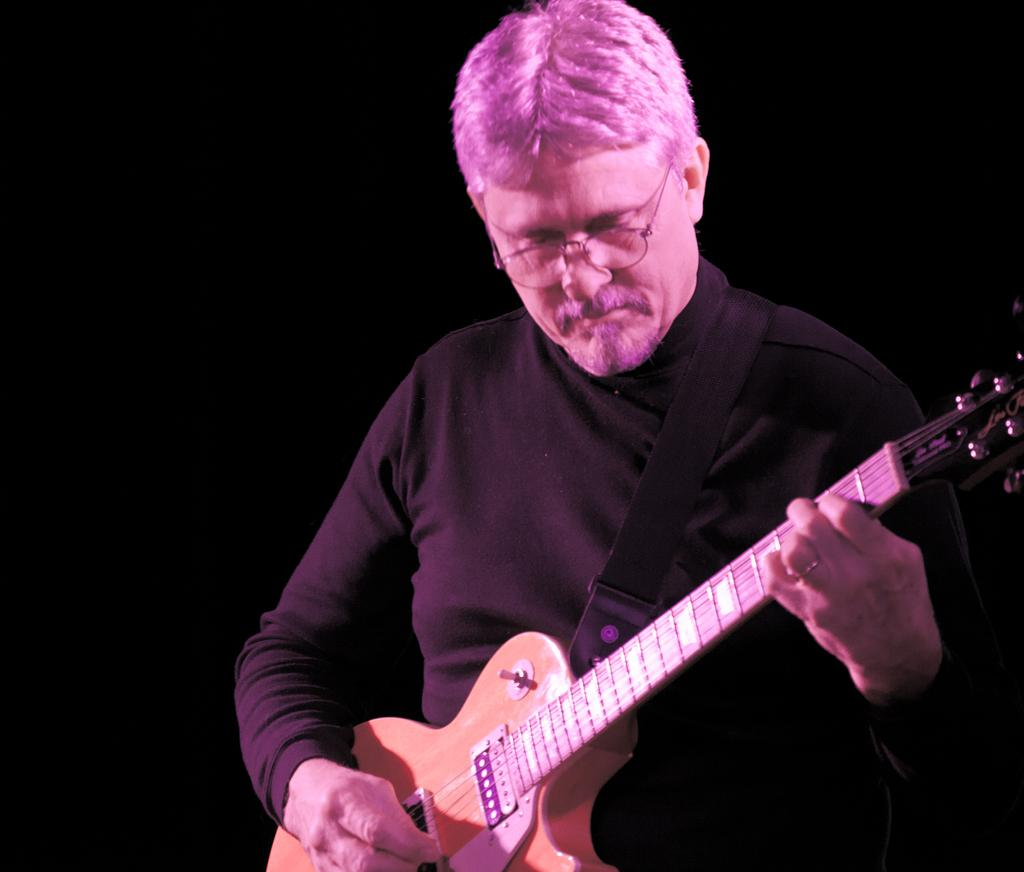Who is the main subject in the image? There is a man in the image. What is the man wearing? The man is wearing spectacles. What is the man holding in the image? The man is holding a guitar. What is the man doing with the guitar? The man is playing the guitar. What can be observed about the background of the image? The background of the image is dark. What type of goat can be seen in the image? There is no goat present in the image; it features a man playing a guitar. What belief system does the man in the image follow? There is no information about the man's belief system in the image. 